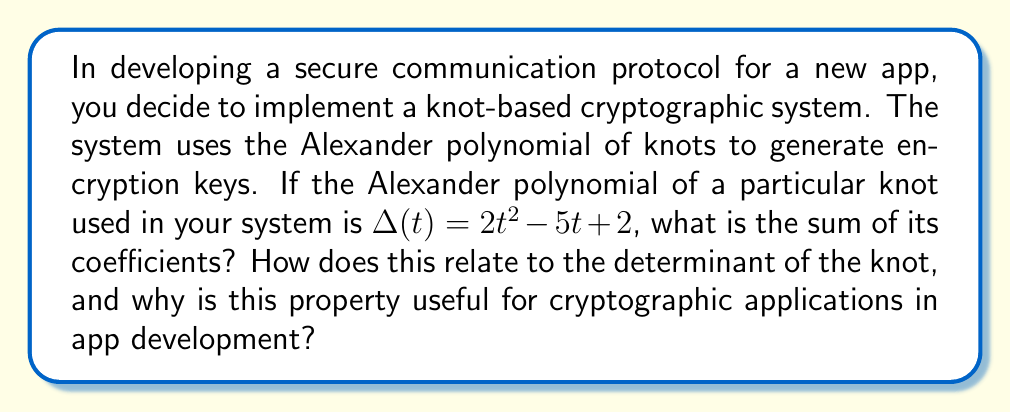Show me your answer to this math problem. 1. The Alexander polynomial of the knot is given as $\Delta(t) = 2t^2 - 5t + 2$.

2. To find the sum of coefficients, we add all the numerical coefficients:
   $2 + (-5) + 2 = -1$

3. The sum of coefficients of the Alexander polynomial is always an odd number for any knot. This is a useful invariant property.

4. The determinant of a knot is defined as the absolute value of the Alexander polynomial evaluated at $t = -1$:
   $|\Delta(-1)| = |2(-1)^2 - 5(-1) + 2| = |2 + 5 + 2| = 9$

5. There's a relationship between the sum of coefficients and the determinant:
   The determinant is always odd, and its parity (odd/even) is the same as the sum of coefficients mod 4.

6. In this case: $-1 \equiv 3 \pmod{4}$, and $9 \equiv 1 \pmod{2}$, confirming the relationship.

7. For cryptographic applications in app development:
   a) The invariant properties of knots (like sum of coefficients and determinant) provide a robust basis for key generation.
   b) These properties are difficult to reverse-engineer, enhancing security.
   c) The relationship between different invariants allows for additional verification steps in the encryption/decryption process.
   d) The computational complexity of calculating knot invariants can be leveraged for creating secure, yet efficient, protocols for mobile apps.
Answer: $-1$; odd determinant, enhancing cryptographic security 